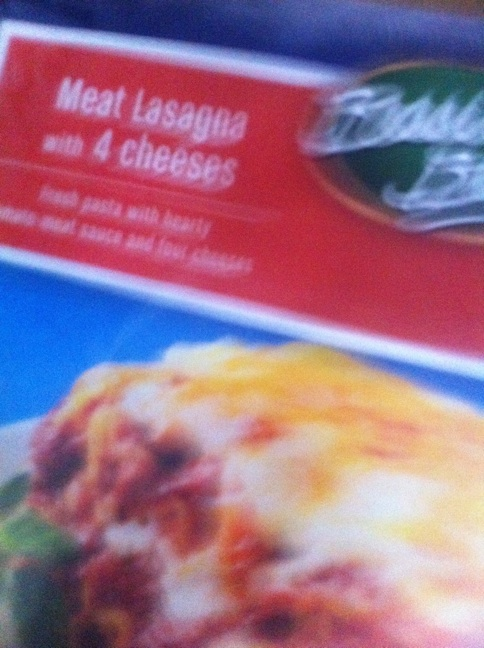Can you tell me more about the type of cheeses used in this lasagna? While the box specifically mentions '4 cheeses,' the exact types aren't visible in the image provided. Typically, a four cheese lasagna might include mozzarella, ricotta, Parmesan, and a variant like Romano or provolone. 